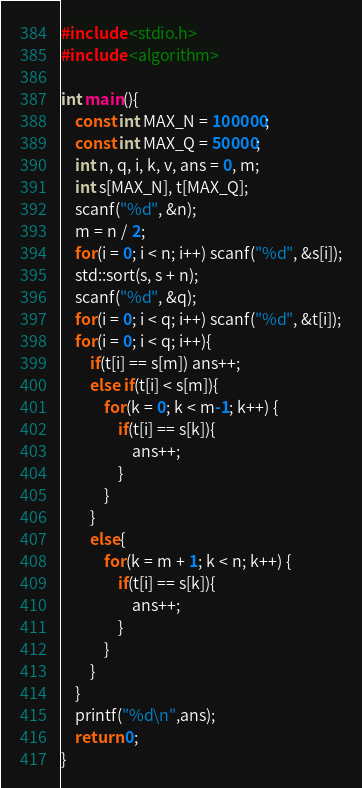<code> <loc_0><loc_0><loc_500><loc_500><_C++_>#include <stdio.h>
#include <algorithm>

int main(){
    const int MAX_N = 100000;
    const int MAX_Q = 50000;
    int n, q, i, k, v, ans = 0, m;
    int s[MAX_N], t[MAX_Q];
    scanf("%d", &n);
    m = n / 2;
    for(i = 0; i < n; i++) scanf("%d", &s[i]);
    std::sort(s, s + n);
    scanf("%d", &q);
    for(i = 0; i < q; i++) scanf("%d", &t[i]);
    for(i = 0; i < q; i++){
        if(t[i] == s[m]) ans++;
        else if(t[i] < s[m]){
            for(k = 0; k < m-1; k++) {
                if(t[i] == s[k]){
                    ans++;
                }
            }
        }
        else{
            for(k = m + 1; k < n; k++) {
                if(t[i] == s[k]){
                    ans++;
                }
            }
        }
    }
    printf("%d\n",ans);
    return 0;
}</code> 